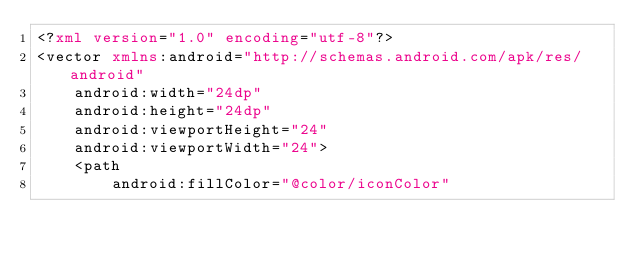Convert code to text. <code><loc_0><loc_0><loc_500><loc_500><_XML_><?xml version="1.0" encoding="utf-8"?>
<vector xmlns:android="http://schemas.android.com/apk/res/android"
    android:width="24dp"
    android:height="24dp"
    android:viewportHeight="24"
    android:viewportWidth="24">
    <path
        android:fillColor="@color/iconColor"</code> 